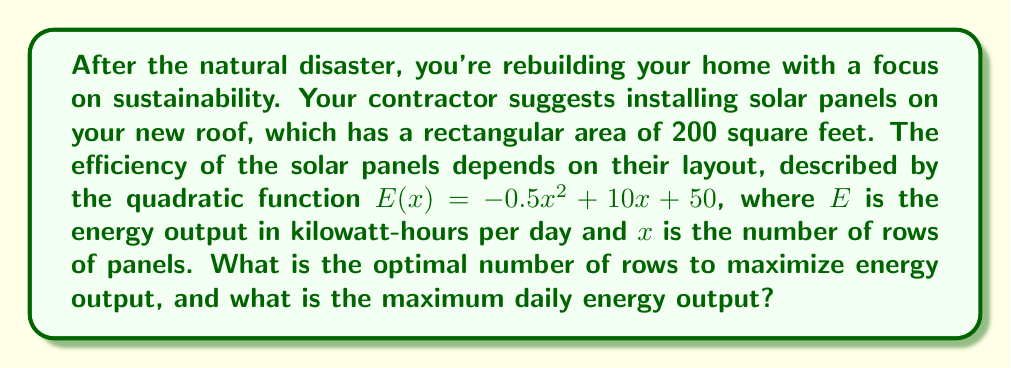Can you solve this math problem? To solve this problem, we need to find the maximum value of the quadratic function $E(x) = -0.5x^2 + 10x + 50$. We can do this by following these steps:

1) For a quadratic function in the form $f(x) = ax^2 + bx + c$, the x-coordinate of the vertex is given by $x = -\frac{b}{2a}$.

2) In our case, $a = -0.5$, $b = 10$, and $c = 50$. Let's substitute these values:

   $x = -\frac{10}{2(-0.5)} = -\frac{10}{-1} = 10$

3) This means the optimal number of rows is 10.

4) To find the maximum energy output, we substitute $x = 10$ into our original function:

   $E(10) = -0.5(10)^2 + 10(10) + 50$
   $= -0.5(100) + 100 + 50$
   $= -50 + 100 + 50$
   $= 100$

5) Therefore, the maximum daily energy output is 100 kilowatt-hours.
Answer: 10 rows; 100 kilowatt-hours per day 